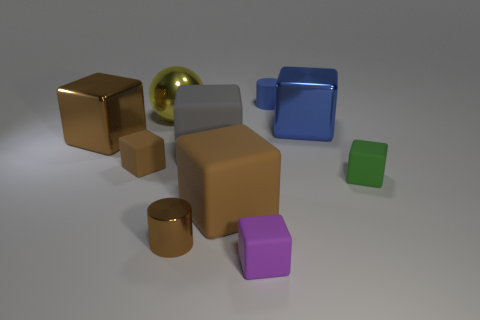Subtract all small purple blocks. How many blocks are left? 6 Subtract all blue cylinders. How many brown cubes are left? 3 Subtract all brown cubes. How many cubes are left? 4 Subtract all cylinders. How many objects are left? 8 Subtract all blue blocks. Subtract all green spheres. How many blocks are left? 6 Subtract 0 cyan cylinders. How many objects are left? 10 Subtract all big yellow rubber objects. Subtract all yellow metallic objects. How many objects are left? 9 Add 1 blue shiny blocks. How many blue shiny blocks are left? 2 Add 6 big shiny balls. How many big shiny balls exist? 7 